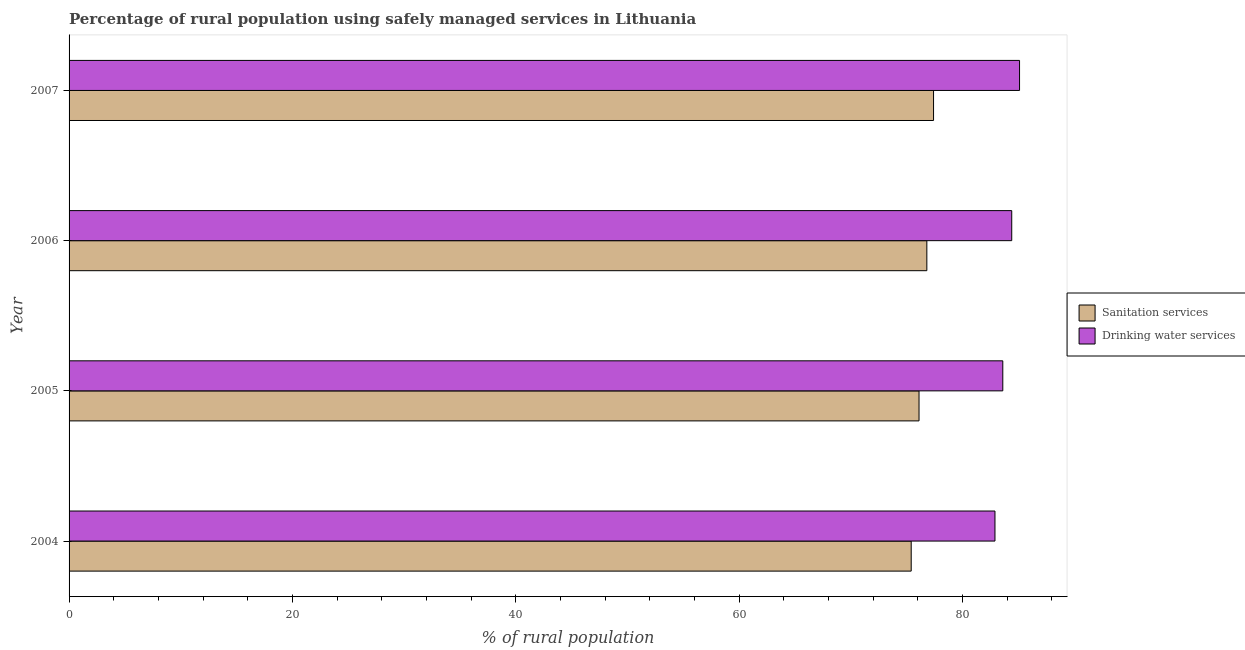Are the number of bars on each tick of the Y-axis equal?
Make the answer very short. Yes. What is the percentage of rural population who used sanitation services in 2006?
Make the answer very short. 76.8. Across all years, what is the maximum percentage of rural population who used drinking water services?
Provide a succinct answer. 85.1. Across all years, what is the minimum percentage of rural population who used sanitation services?
Provide a succinct answer. 75.4. What is the total percentage of rural population who used sanitation services in the graph?
Keep it short and to the point. 305.7. What is the difference between the percentage of rural population who used drinking water services in 2006 and the percentage of rural population who used sanitation services in 2007?
Give a very brief answer. 7. What is the average percentage of rural population who used sanitation services per year?
Offer a terse response. 76.42. In the year 2006, what is the difference between the percentage of rural population who used sanitation services and percentage of rural population who used drinking water services?
Offer a very short reply. -7.6. In how many years, is the percentage of rural population who used drinking water services greater than 40 %?
Ensure brevity in your answer.  4. What is the ratio of the percentage of rural population who used drinking water services in 2004 to that in 2007?
Provide a succinct answer. 0.97. Is the percentage of rural population who used drinking water services in 2005 less than that in 2006?
Keep it short and to the point. Yes. Is the sum of the percentage of rural population who used sanitation services in 2004 and 2006 greater than the maximum percentage of rural population who used drinking water services across all years?
Offer a terse response. Yes. What does the 1st bar from the top in 2004 represents?
Ensure brevity in your answer.  Drinking water services. What does the 1st bar from the bottom in 2004 represents?
Give a very brief answer. Sanitation services. How many bars are there?
Make the answer very short. 8. How many years are there in the graph?
Offer a terse response. 4. Are the values on the major ticks of X-axis written in scientific E-notation?
Offer a very short reply. No. Does the graph contain any zero values?
Your answer should be very brief. No. Does the graph contain grids?
Make the answer very short. No. What is the title of the graph?
Ensure brevity in your answer.  Percentage of rural population using safely managed services in Lithuania. Does "Urban Population" appear as one of the legend labels in the graph?
Offer a very short reply. No. What is the label or title of the X-axis?
Your answer should be compact. % of rural population. What is the % of rural population in Sanitation services in 2004?
Keep it short and to the point. 75.4. What is the % of rural population in Drinking water services in 2004?
Your answer should be compact. 82.9. What is the % of rural population in Sanitation services in 2005?
Offer a terse response. 76.1. What is the % of rural population in Drinking water services in 2005?
Give a very brief answer. 83.6. What is the % of rural population of Sanitation services in 2006?
Your answer should be compact. 76.8. What is the % of rural population of Drinking water services in 2006?
Keep it short and to the point. 84.4. What is the % of rural population in Sanitation services in 2007?
Your answer should be compact. 77.4. What is the % of rural population of Drinking water services in 2007?
Your response must be concise. 85.1. Across all years, what is the maximum % of rural population in Sanitation services?
Offer a terse response. 77.4. Across all years, what is the maximum % of rural population of Drinking water services?
Ensure brevity in your answer.  85.1. Across all years, what is the minimum % of rural population in Sanitation services?
Provide a succinct answer. 75.4. Across all years, what is the minimum % of rural population of Drinking water services?
Make the answer very short. 82.9. What is the total % of rural population in Sanitation services in the graph?
Provide a short and direct response. 305.7. What is the total % of rural population in Drinking water services in the graph?
Make the answer very short. 336. What is the difference between the % of rural population in Sanitation services in 2004 and that in 2005?
Your answer should be very brief. -0.7. What is the difference between the % of rural population in Drinking water services in 2004 and that in 2005?
Make the answer very short. -0.7. What is the difference between the % of rural population in Sanitation services in 2004 and that in 2006?
Your response must be concise. -1.4. What is the difference between the % of rural population of Sanitation services in 2005 and that in 2006?
Give a very brief answer. -0.7. What is the difference between the % of rural population of Drinking water services in 2005 and that in 2007?
Provide a short and direct response. -1.5. What is the difference between the % of rural population in Sanitation services in 2006 and that in 2007?
Give a very brief answer. -0.6. What is the difference between the % of rural population of Drinking water services in 2006 and that in 2007?
Provide a short and direct response. -0.7. What is the difference between the % of rural population of Sanitation services in 2004 and the % of rural population of Drinking water services in 2007?
Ensure brevity in your answer.  -9.7. What is the difference between the % of rural population of Sanitation services in 2005 and the % of rural population of Drinking water services in 2006?
Offer a terse response. -8.3. What is the average % of rural population in Sanitation services per year?
Ensure brevity in your answer.  76.42. In the year 2004, what is the difference between the % of rural population of Sanitation services and % of rural population of Drinking water services?
Provide a short and direct response. -7.5. In the year 2005, what is the difference between the % of rural population of Sanitation services and % of rural population of Drinking water services?
Your response must be concise. -7.5. In the year 2006, what is the difference between the % of rural population of Sanitation services and % of rural population of Drinking water services?
Give a very brief answer. -7.6. What is the ratio of the % of rural population of Sanitation services in 2004 to that in 2006?
Make the answer very short. 0.98. What is the ratio of the % of rural population of Drinking water services in 2004 to that in 2006?
Your answer should be very brief. 0.98. What is the ratio of the % of rural population of Sanitation services in 2004 to that in 2007?
Give a very brief answer. 0.97. What is the ratio of the % of rural population of Drinking water services in 2004 to that in 2007?
Your answer should be very brief. 0.97. What is the ratio of the % of rural population of Sanitation services in 2005 to that in 2006?
Your response must be concise. 0.99. What is the ratio of the % of rural population in Sanitation services in 2005 to that in 2007?
Keep it short and to the point. 0.98. What is the ratio of the % of rural population of Drinking water services in 2005 to that in 2007?
Give a very brief answer. 0.98. What is the ratio of the % of rural population of Drinking water services in 2006 to that in 2007?
Your answer should be compact. 0.99. What is the difference between the highest and the second highest % of rural population in Sanitation services?
Ensure brevity in your answer.  0.6. What is the difference between the highest and the lowest % of rural population in Sanitation services?
Provide a short and direct response. 2. 